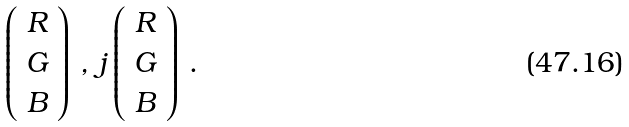Convert formula to latex. <formula><loc_0><loc_0><loc_500><loc_500>\left ( \begin{array} { c } { R } \\ { G } \\ { B } \end{array} \right ) \, , \, j \left ( \begin{array} { c } { R } \\ { G } \\ { B } \end{array} \right ) \, .</formula> 